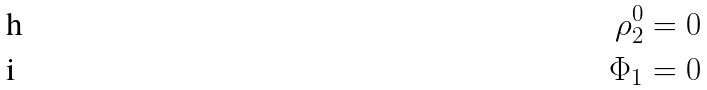<formula> <loc_0><loc_0><loc_500><loc_500>\rho _ { 2 } ^ { 0 } & = 0 \\ \Phi _ { 1 } & = 0</formula> 